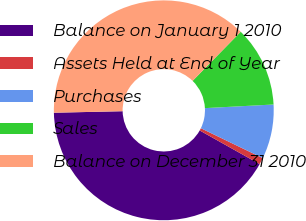Convert chart. <chart><loc_0><loc_0><loc_500><loc_500><pie_chart><fcel>Balance on January 1 2010<fcel>Assets Held at End of Year<fcel>Purchases<fcel>Sales<fcel>Balance on December 31 2010<nl><fcel>41.51%<fcel>0.98%<fcel>8.0%<fcel>11.83%<fcel>37.68%<nl></chart> 